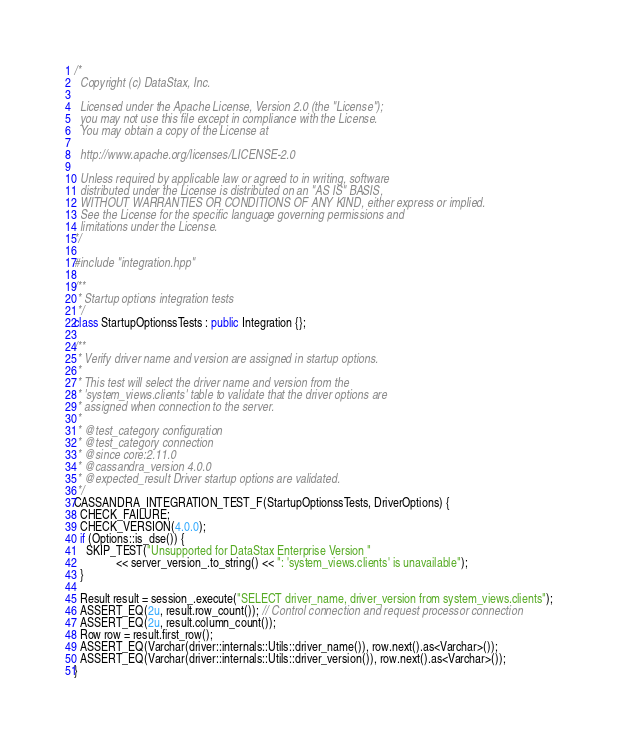Convert code to text. <code><loc_0><loc_0><loc_500><loc_500><_C++_>/*
  Copyright (c) DataStax, Inc.

  Licensed under the Apache License, Version 2.0 (the "License");
  you may not use this file except in compliance with the License.
  You may obtain a copy of the License at

  http://www.apache.org/licenses/LICENSE-2.0

  Unless required by applicable law or agreed to in writing, software
  distributed under the License is distributed on an "AS IS" BASIS,
  WITHOUT WARRANTIES OR CONDITIONS OF ANY KIND, either express or implied.
  See the License for the specific language governing permissions and
  limitations under the License.
*/

#include "integration.hpp"

/**
 * Startup options integration tests
 */
class StartupOptionssTests : public Integration {};

/**
 * Verify driver name and version are assigned in startup options.
 *
 * This test will select the driver name and version from the
 * 'system_views.clients' table to validate that the driver options are
 * assigned when connection to the server.
 *
 * @test_category configuration
 * @test_category connection
 * @since core:2.11.0
 * @cassandra_version 4.0.0
 * @expected_result Driver startup options are validated.
 */
CASSANDRA_INTEGRATION_TEST_F(StartupOptionssTests, DriverOptions) {
  CHECK_FAILURE;
  CHECK_VERSION(4.0.0);
  if (Options::is_dse()) {
    SKIP_TEST("Unsupported for DataStax Enterprise Version "
              << server_version_.to_string() << ": 'system_views.clients' is unavailable");
  }

  Result result = session_.execute("SELECT driver_name, driver_version from system_views.clients");
  ASSERT_EQ(2u, result.row_count()); // Control connection and request processor connection
  ASSERT_EQ(2u, result.column_count());
  Row row = result.first_row();
  ASSERT_EQ(Varchar(driver::internals::Utils::driver_name()), row.next().as<Varchar>());
  ASSERT_EQ(Varchar(driver::internals::Utils::driver_version()), row.next().as<Varchar>());
}
</code> 